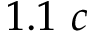Convert formula to latex. <formula><loc_0><loc_0><loc_500><loc_500>1 . 1 c</formula> 